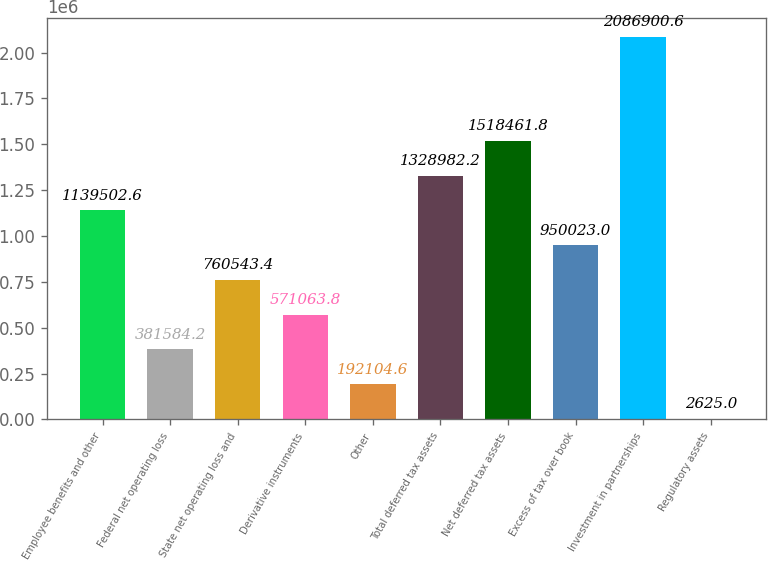<chart> <loc_0><loc_0><loc_500><loc_500><bar_chart><fcel>Employee benefits and other<fcel>Federal net operating loss<fcel>State net operating loss and<fcel>Derivative instruments<fcel>Other<fcel>Total deferred tax assets<fcel>Net deferred tax assets<fcel>Excess of tax over book<fcel>Investment in partnerships<fcel>Regulatory assets<nl><fcel>1.1395e+06<fcel>381584<fcel>760543<fcel>571064<fcel>192105<fcel>1.32898e+06<fcel>1.51846e+06<fcel>950023<fcel>2.0869e+06<fcel>2625<nl></chart> 